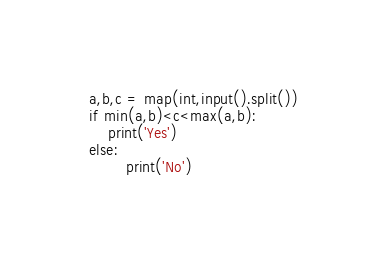Convert code to text. <code><loc_0><loc_0><loc_500><loc_500><_Python_>a,b,c = map(int,input().split())
if min(a,b)<c<max(a,b):
    print('Yes')
else:
        print('No')</code> 